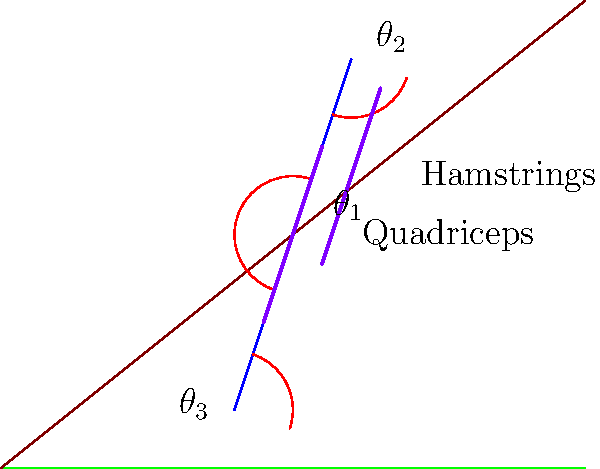As a hiker ascending steep terrain in the Rogaland region, which joint angle ($\theta_1$, $\theta_2$, or $\theta_3$) is most critical for maintaining balance and control, and which muscle group (quadriceps or hamstrings) is likely to show the highest activation during this ascent? To answer this question, let's analyze the biomechanics of hiking on steep terrain:

1. Joint angles:
   $\theta_1$: Knee angle
   $\theta_2$: Hip angle
   $\theta_3$: Ankle angle

2. The ankle angle ($\theta_3$) is most critical for maintaining balance and control on steep terrain:
   a. It allows for adaptation to the slope
   b. It helps in maintaining the center of gravity
   c. It provides stability and prevents falling backward

3. Muscle activation:
   a. Quadriceps: Extend the knee and assist in hip flexion
   b. Hamstrings: Flex the knee and extend the hip

4. During ascent on steep terrain:
   a. The quadriceps show higher activation:
      - They work to extend the knee, pushing the body upward
      - They help maintain an upright posture against gravity
   b. The hamstrings are less active during the ascent phase

5. The quadriceps' higher activation is crucial for:
   a. Propelling the body upward
   b. Stabilizing the knee joint
   c. Controlling the rate of knee flexion during weight acceptance

Therefore, the ankle angle ($\theta_3$) is most critical for balance and control, while the quadriceps muscle group shows the highest activation during steep ascents.
Answer: $\theta_3$ (ankle angle); quadriceps 